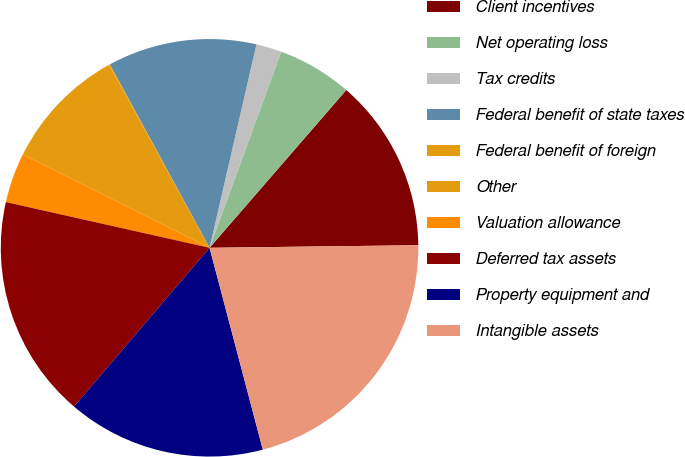<chart> <loc_0><loc_0><loc_500><loc_500><pie_chart><fcel>Client incentives<fcel>Net operating loss<fcel>Tax credits<fcel>Federal benefit of state taxes<fcel>Federal benefit of foreign<fcel>Other<fcel>Valuation allowance<fcel>Deferred tax assets<fcel>Property equipment and<fcel>Intangible assets<nl><fcel>13.44%<fcel>5.79%<fcel>1.97%<fcel>11.53%<fcel>0.06%<fcel>9.62%<fcel>3.88%<fcel>17.27%<fcel>15.35%<fcel>21.09%<nl></chart> 